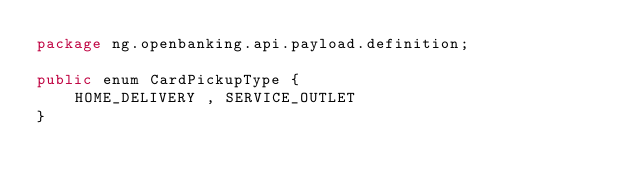<code> <loc_0><loc_0><loc_500><loc_500><_Java_>package ng.openbanking.api.payload.definition;

public enum CardPickupType {
    HOME_DELIVERY , SERVICE_OUTLET
}
</code> 